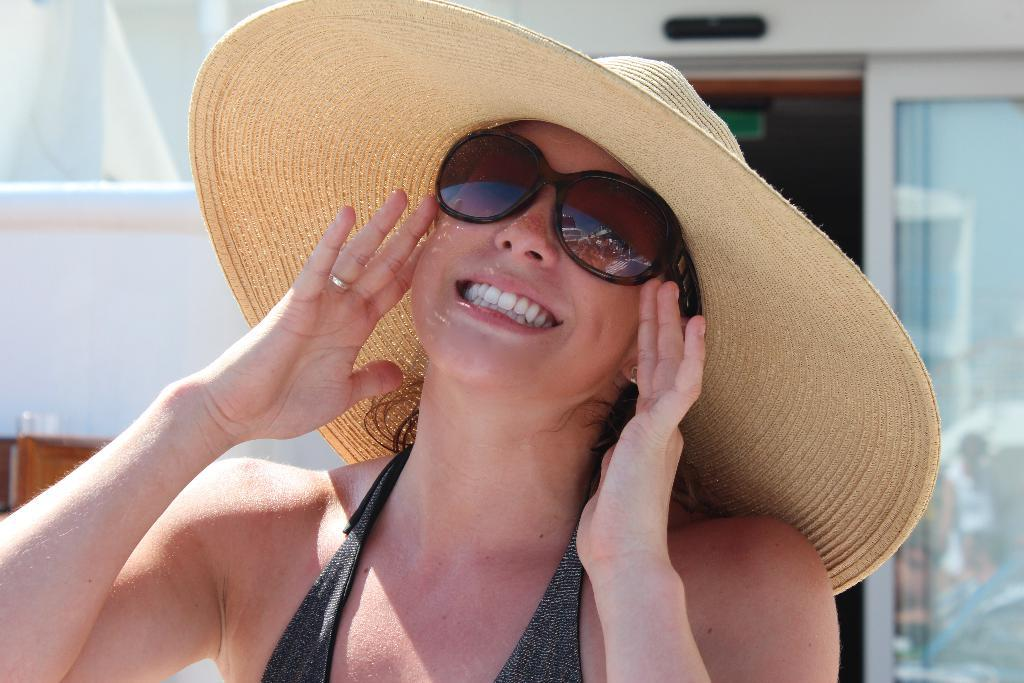Who is the main subject in the image? There is a woman in the image. What is the woman wearing? The woman is wearing a dress, glasses, and a hat. What is the woman's facial expression? The woman is smiling. Can you describe the background of the image? The background of the image is slightly blurred, and there are glass doors and a wall visible. What type of pan is the woman using to cook in the image? There is no pan or cooking activity present in the image. Can you tell me how many baskets are visible in the image? There are no baskets present in the image. 